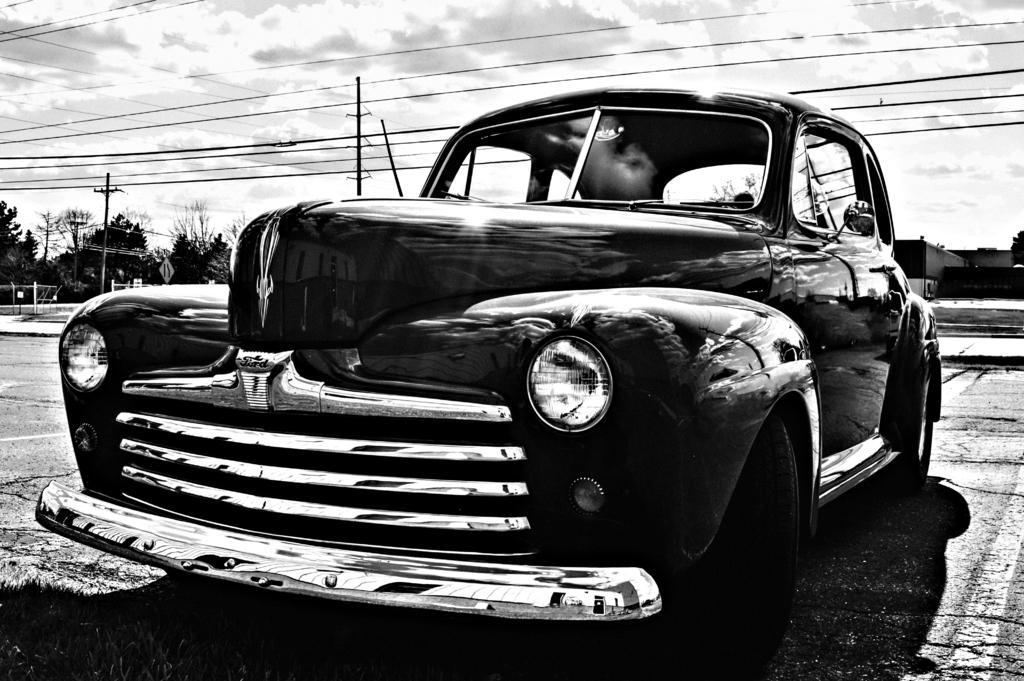In one or two sentences, can you explain what this image depicts? This is a black and white image. Here I can see a car on the ground. In the background there are some buildings and trees and also I can see poles. On the top of the image I can see the sky and wires. 